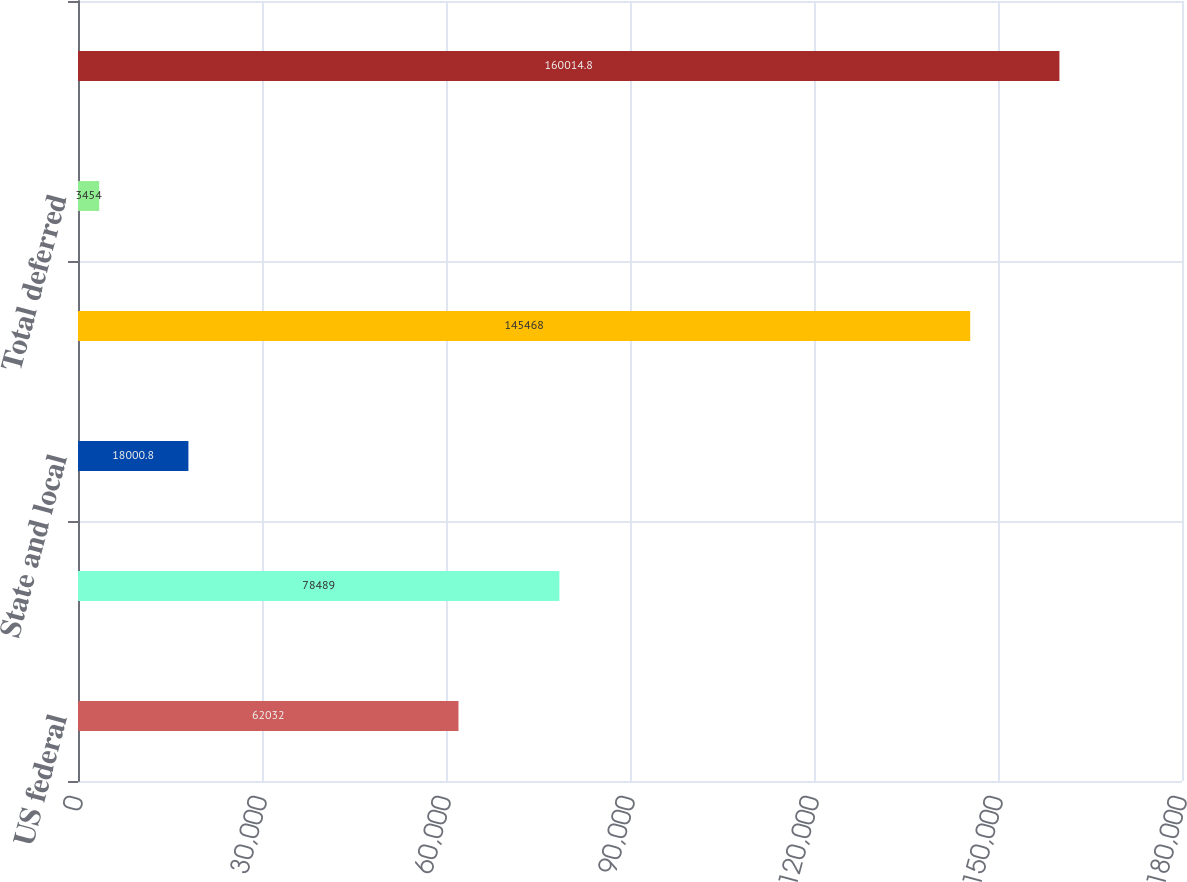<chart> <loc_0><loc_0><loc_500><loc_500><bar_chart><fcel>US federal<fcel>Non-US<fcel>State and local<fcel>Total current<fcel>Total deferred<fcel>Total provision<nl><fcel>62032<fcel>78489<fcel>18000.8<fcel>145468<fcel>3454<fcel>160015<nl></chart> 